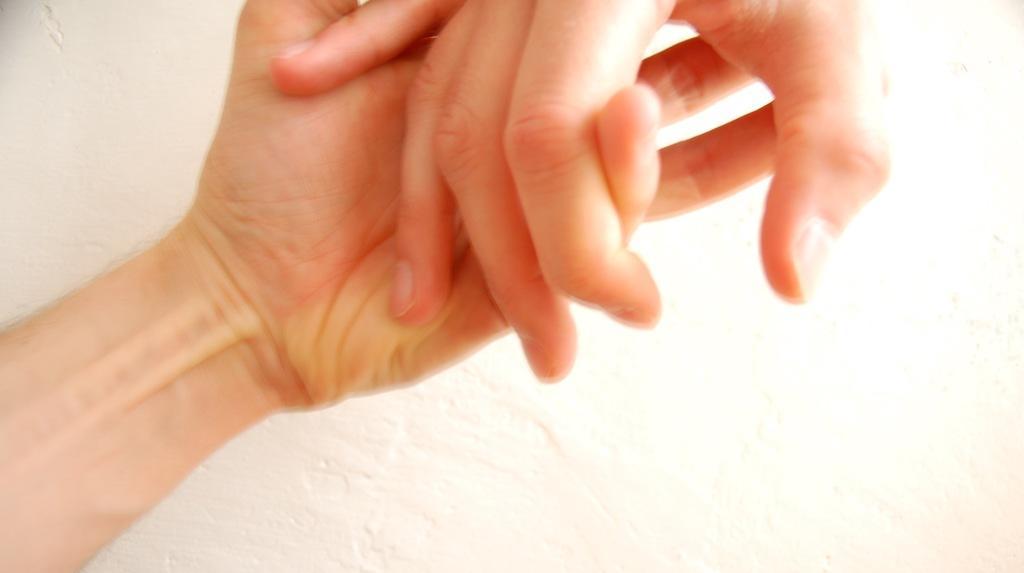How would you summarize this image in a sentence or two? In this picture there are two persons holding hands of each other. 